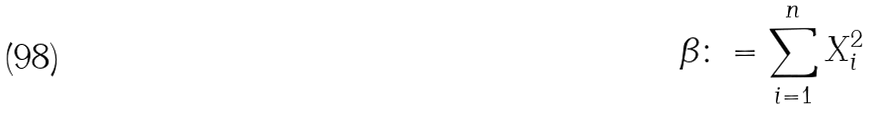<formula> <loc_0><loc_0><loc_500><loc_500>\beta \colon = \sum _ { i = 1 } ^ { n } X _ { i } ^ { 2 }</formula> 